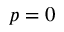<formula> <loc_0><loc_0><loc_500><loc_500>p = 0</formula> 